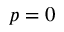<formula> <loc_0><loc_0><loc_500><loc_500>p = 0</formula> 